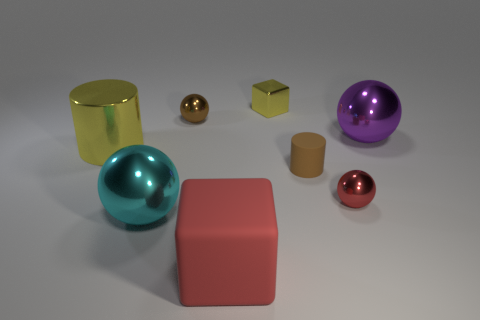Subtract all brown metal spheres. How many spheres are left? 3 Add 1 red cubes. How many objects exist? 9 Subtract all cylinders. How many objects are left? 6 Subtract all red spheres. How many spheres are left? 3 Subtract 2 balls. How many balls are left? 2 Add 2 tiny brown matte things. How many tiny brown matte things exist? 3 Subtract 1 cyan spheres. How many objects are left? 7 Subtract all brown cylinders. Subtract all purple blocks. How many cylinders are left? 1 Subtract all gray blocks. Subtract all brown matte objects. How many objects are left? 7 Add 4 tiny matte objects. How many tiny matte objects are left? 5 